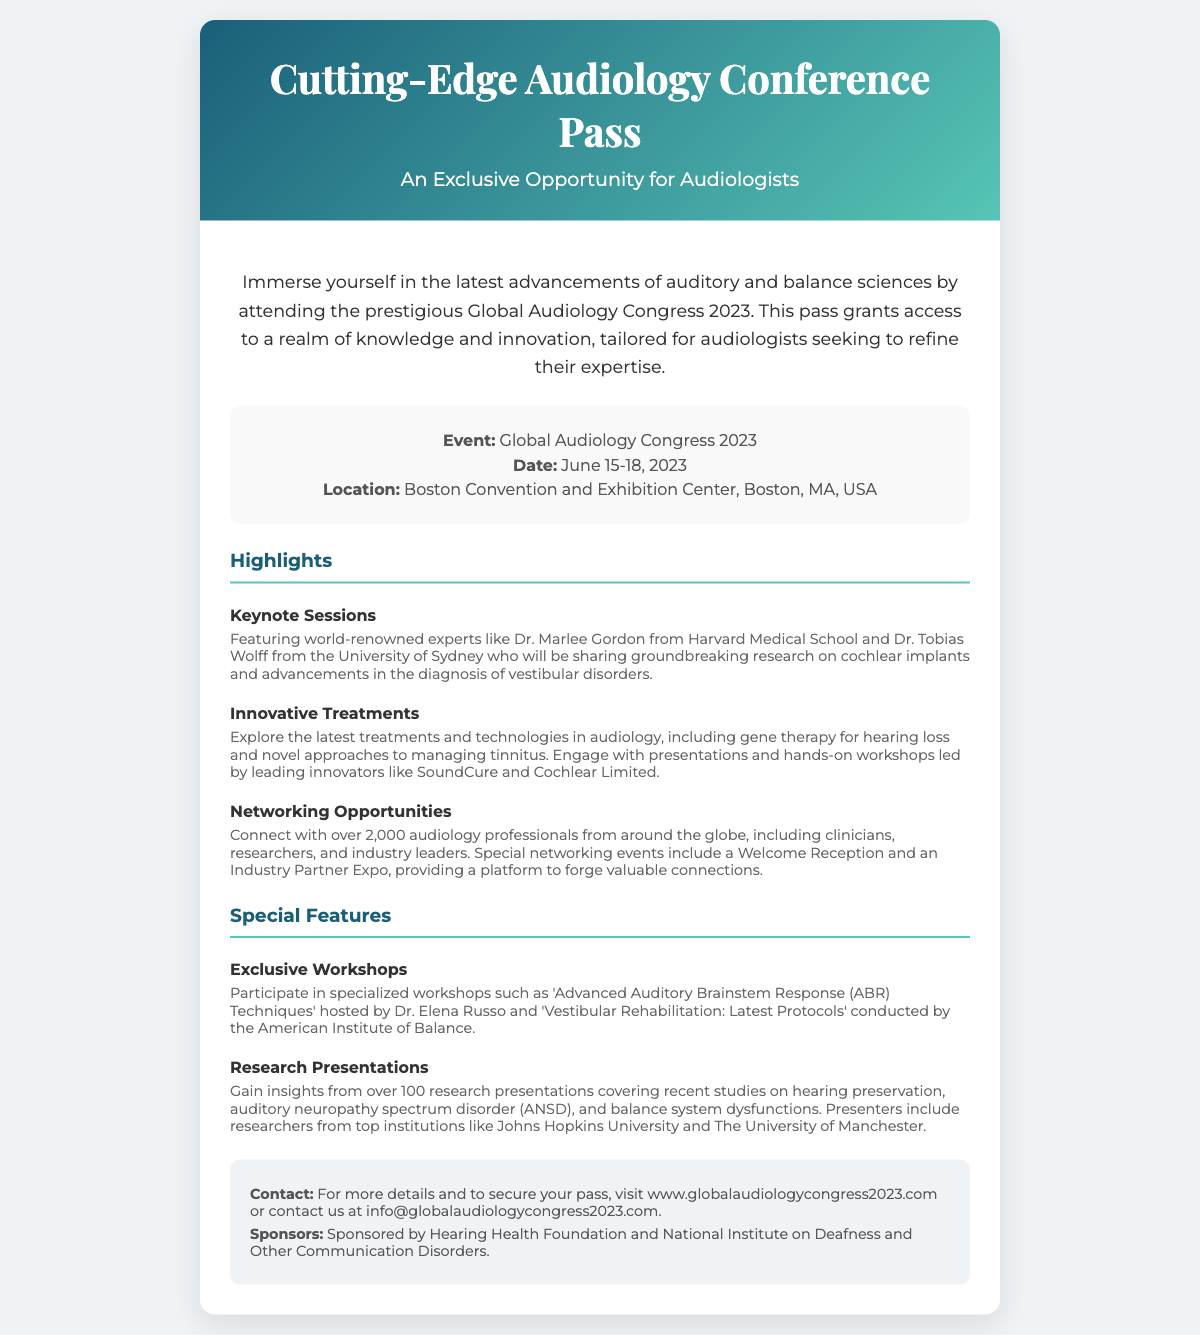What is the event name? The event name is highlighted in the details section of the document.
Answer: Global Audiology Congress 2023 What are the dates of the conference? The dates for the conference are specified in the details section.
Answer: June 15-18, 2023 Where is the conference located? The location is clearly stated in the details section of the document.
Answer: Boston Convention and Exhibition Center, Boston, MA, USA Who are some of the keynote speakers? The keynote speakers are mentioned in the highlights section, referring to their notable affiliations.
Answer: Dr. Marlee Gordon and Dr. Tobias Wolff What type of innovative treatments will be discussed? The types of treatments are listed in the highlights under that category.
Answer: Gene therapy for hearing loss How many audiology professionals are expected to attend? The expected number of professionals is mentioned in the networking opportunities section.
Answer: Over 2,000 What workshop is hosted by Dr. Elena Russo? The specific workshop hosted by Dr. Elena Russo is included in the special features section.
Answer: Advanced Auditory Brainstem Response (ABR) Techniques What organization sponsors the event? The sponsors are listed in the additional info section of the document.
Answer: Hearing Health Foundation How can one secure a pass for the conference? The method to secure a pass is described in the additional information section.
Answer: Visit www.globalaudiologycongress2023.com 